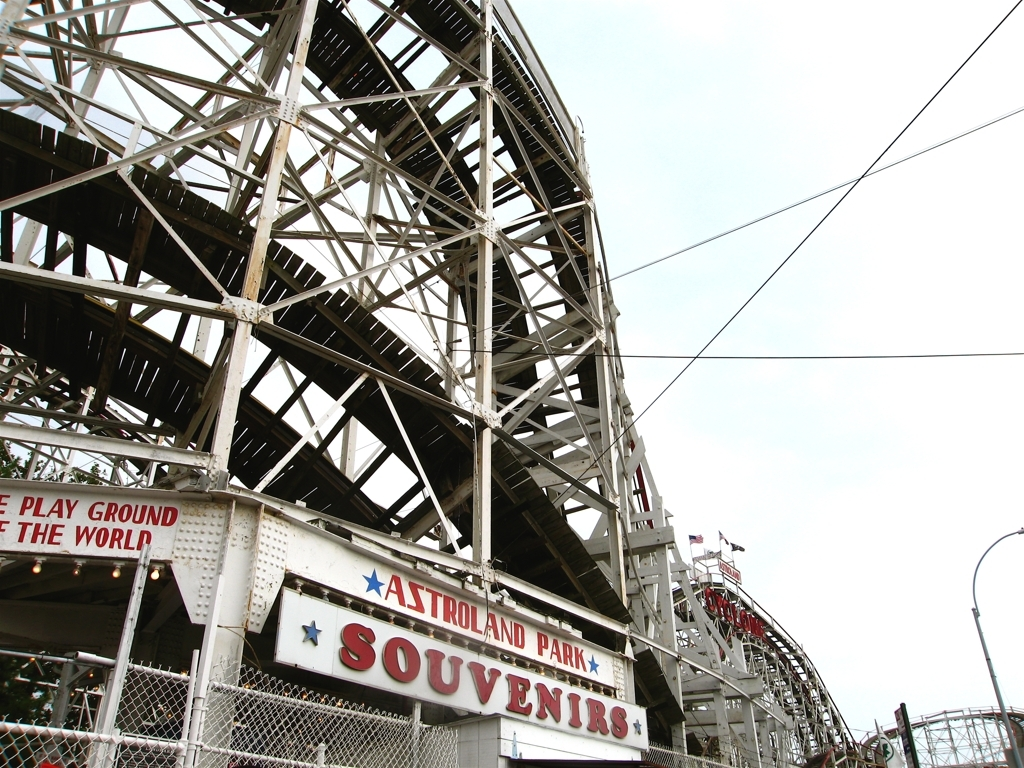Are there any unique technical features visible in the image? While the image does not provide close-up details of the ride's mechanics, the visible framework showcases the complexity typical of wooden roller coasters with numerous beams, braces, and bolts. The overlapping patterns of the beams are crucial for distributing the dynamic forces throughout the ride and ensuring safety and stability. 